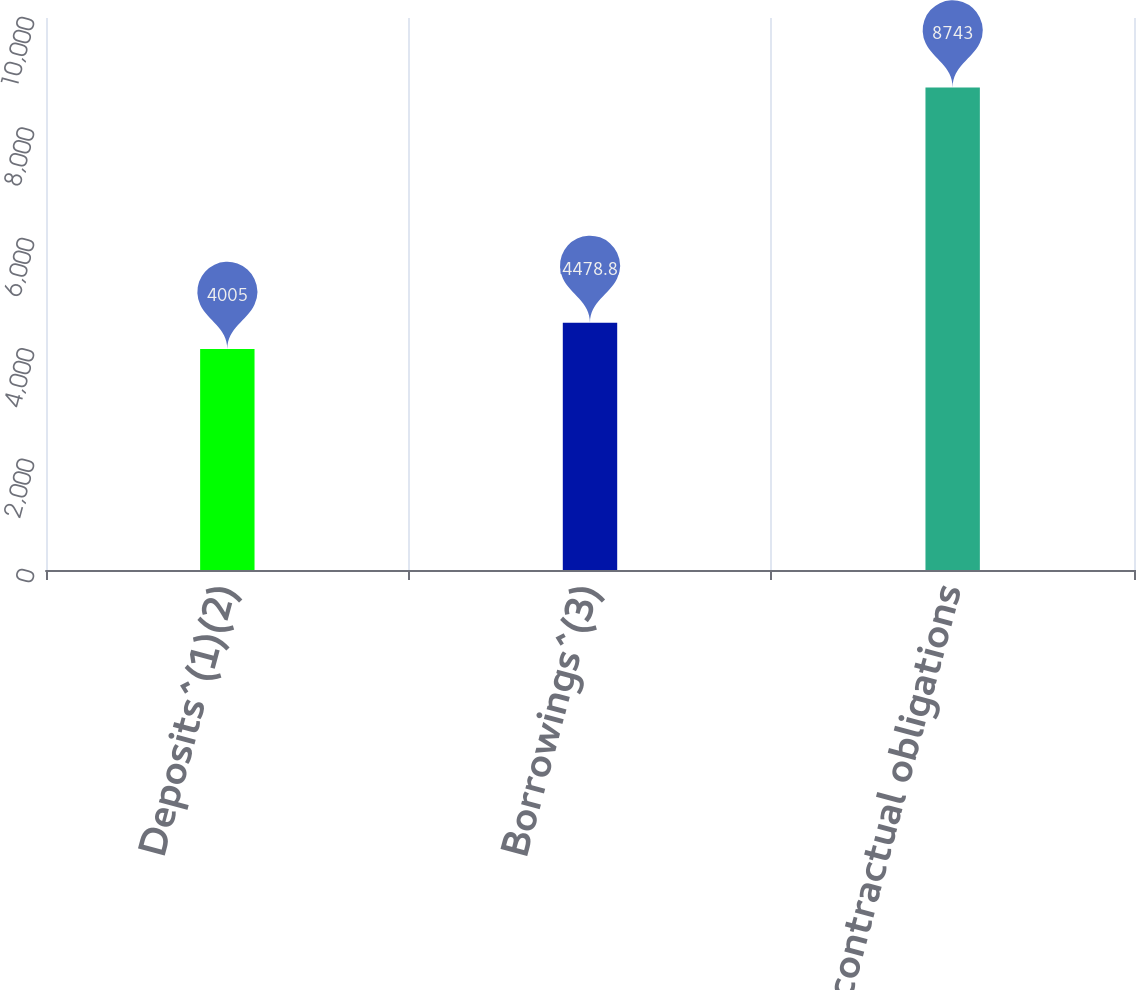<chart> <loc_0><loc_0><loc_500><loc_500><bar_chart><fcel>Deposits^(1)(2)<fcel>Borrowings^(3)<fcel>Total contractual obligations<nl><fcel>4005<fcel>4478.8<fcel>8743<nl></chart> 